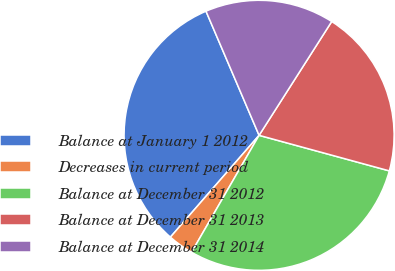<chart> <loc_0><loc_0><loc_500><loc_500><pie_chart><fcel>Balance at January 1 2012<fcel>Decreases in current period<fcel>Balance at December 31 2012<fcel>Balance at December 31 2013<fcel>Balance at December 31 2014<nl><fcel>32.16%<fcel>3.07%<fcel>29.09%<fcel>20.2%<fcel>15.47%<nl></chart> 